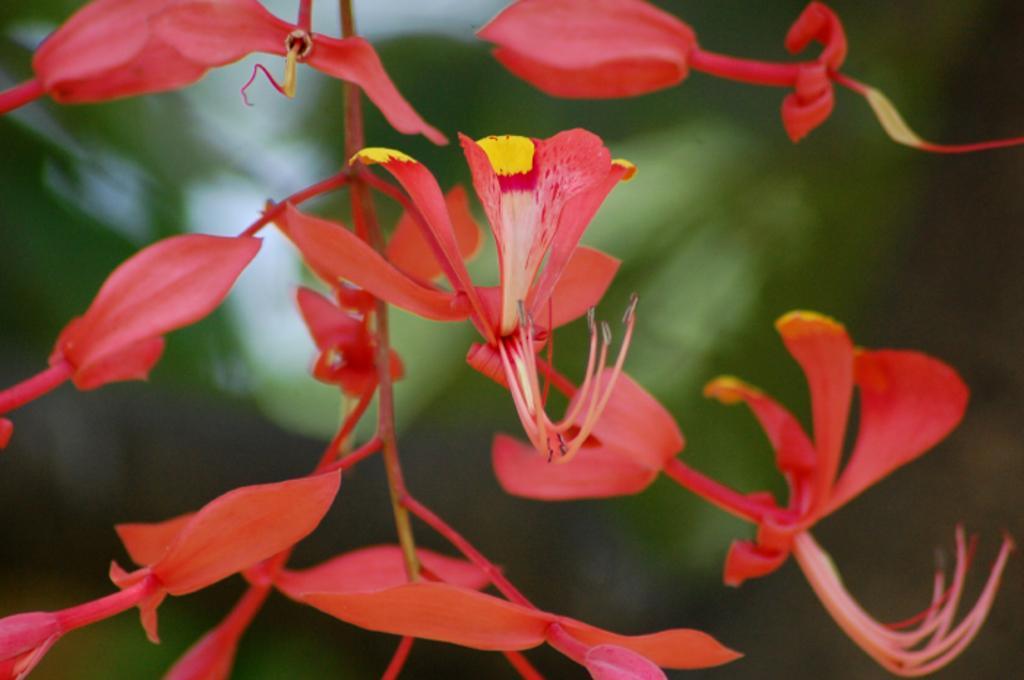Please provide a concise description of this image. In this image we can see a plant with flowers. In the background the image is blur but we can see objects. 